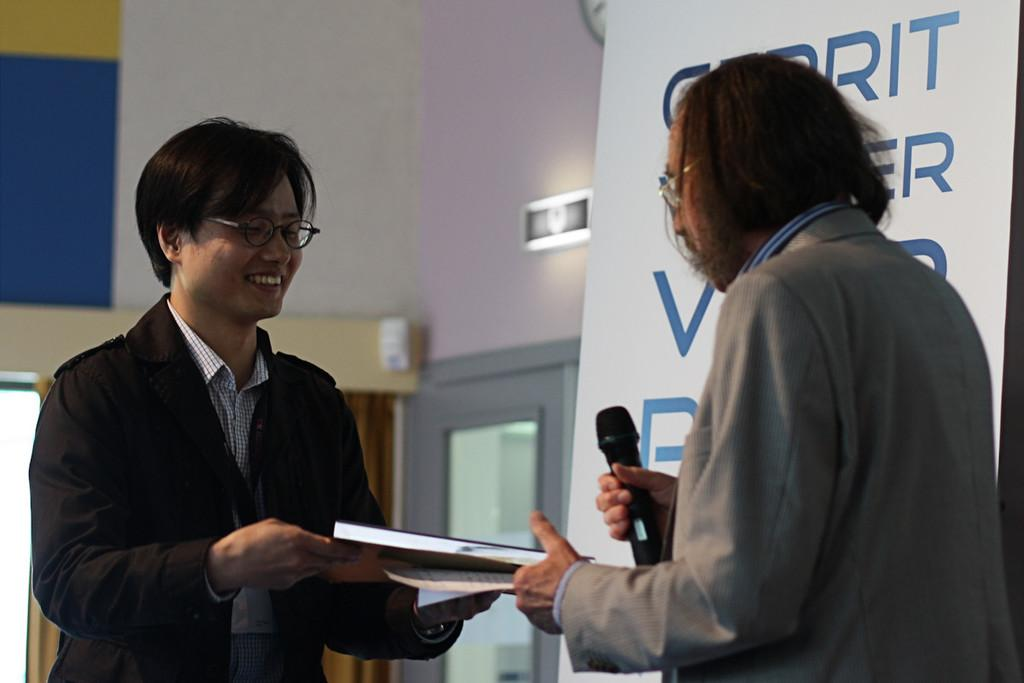How many people are in the image? There are two persons in the image. What are the two persons holding in the image? One person is holding a book, and the other person is holding a microphone. What can be seen in the background of the image? There is a banner visible in the image. What architectural feature is present in the image? There is a door in the image, and it is connected to a wall. How many nails are visible in the image? There are no nails visible in the image. What type of bike is leaning against the wall in the image? There is no bike present in the image. 